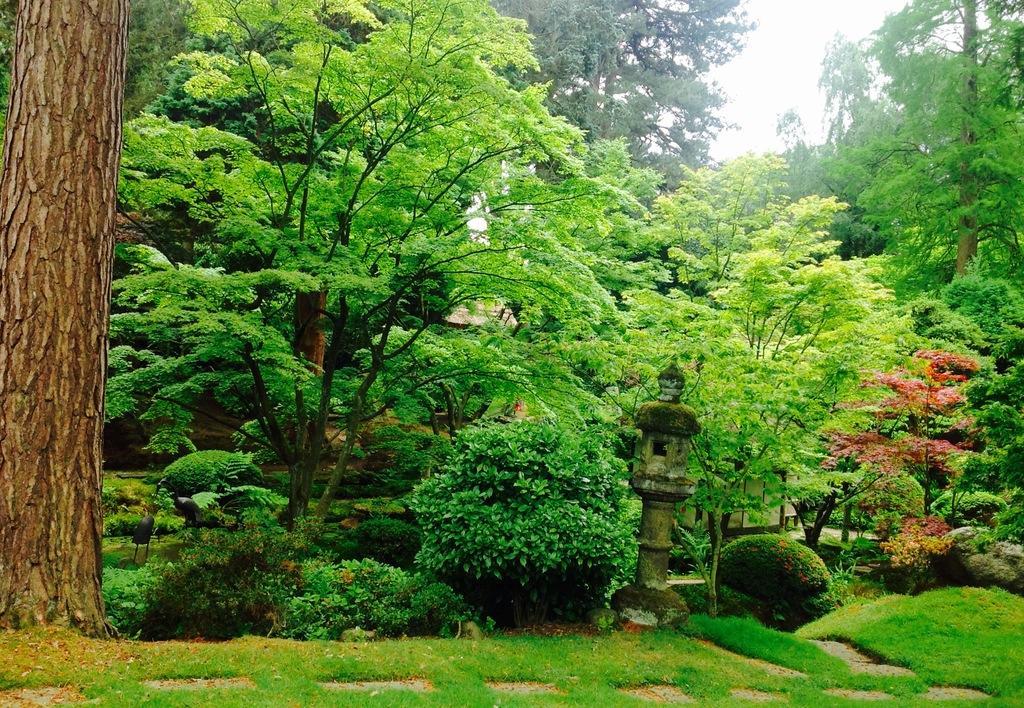Describe this image in one or two sentences. In this image I can see many trees. In-front of these trees there is a pole on the ground. In the back I can see the white sky. 